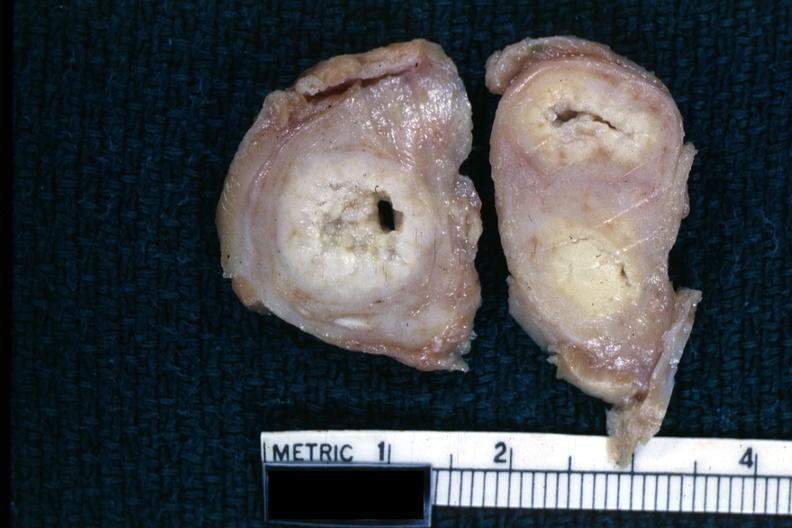what does this image show?
Answer the question using a single word or phrase. Fixed tissue of tuberculosis 